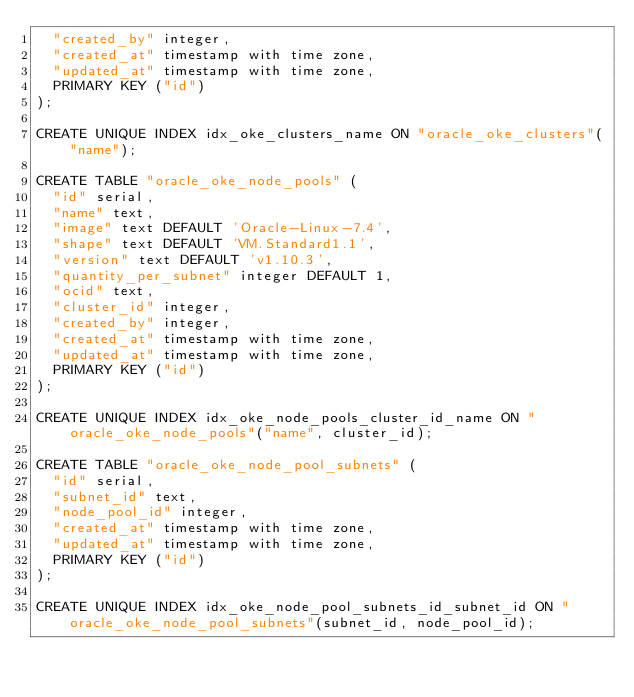Convert code to text. <code><loc_0><loc_0><loc_500><loc_500><_SQL_>  "created_by" integer,
  "created_at" timestamp with time zone,
  "updated_at" timestamp with time zone,
  PRIMARY KEY ("id")
);

CREATE UNIQUE INDEX idx_oke_clusters_name ON "oracle_oke_clusters"("name");

CREATE TABLE "oracle_oke_node_pools" (
  "id" serial,
  "name" text,
  "image" text DEFAULT 'Oracle-Linux-7.4',
  "shape" text DEFAULT 'VM.Standard1.1',
  "version" text DEFAULT 'v1.10.3',
  "quantity_per_subnet" integer DEFAULT 1,
  "ocid" text,
  "cluster_id" integer,
  "created_by" integer,
  "created_at" timestamp with time zone,
  "updated_at" timestamp with time zone,
  PRIMARY KEY ("id")
);

CREATE UNIQUE INDEX idx_oke_node_pools_cluster_id_name ON "oracle_oke_node_pools"("name", cluster_id);

CREATE TABLE "oracle_oke_node_pool_subnets" (
  "id" serial,
  "subnet_id" text,
  "node_pool_id" integer,
  "created_at" timestamp with time zone,
  "updated_at" timestamp with time zone,
  PRIMARY KEY ("id")
);

CREATE UNIQUE INDEX idx_oke_node_pool_subnets_id_subnet_id ON "oracle_oke_node_pool_subnets"(subnet_id, node_pool_id);
</code> 